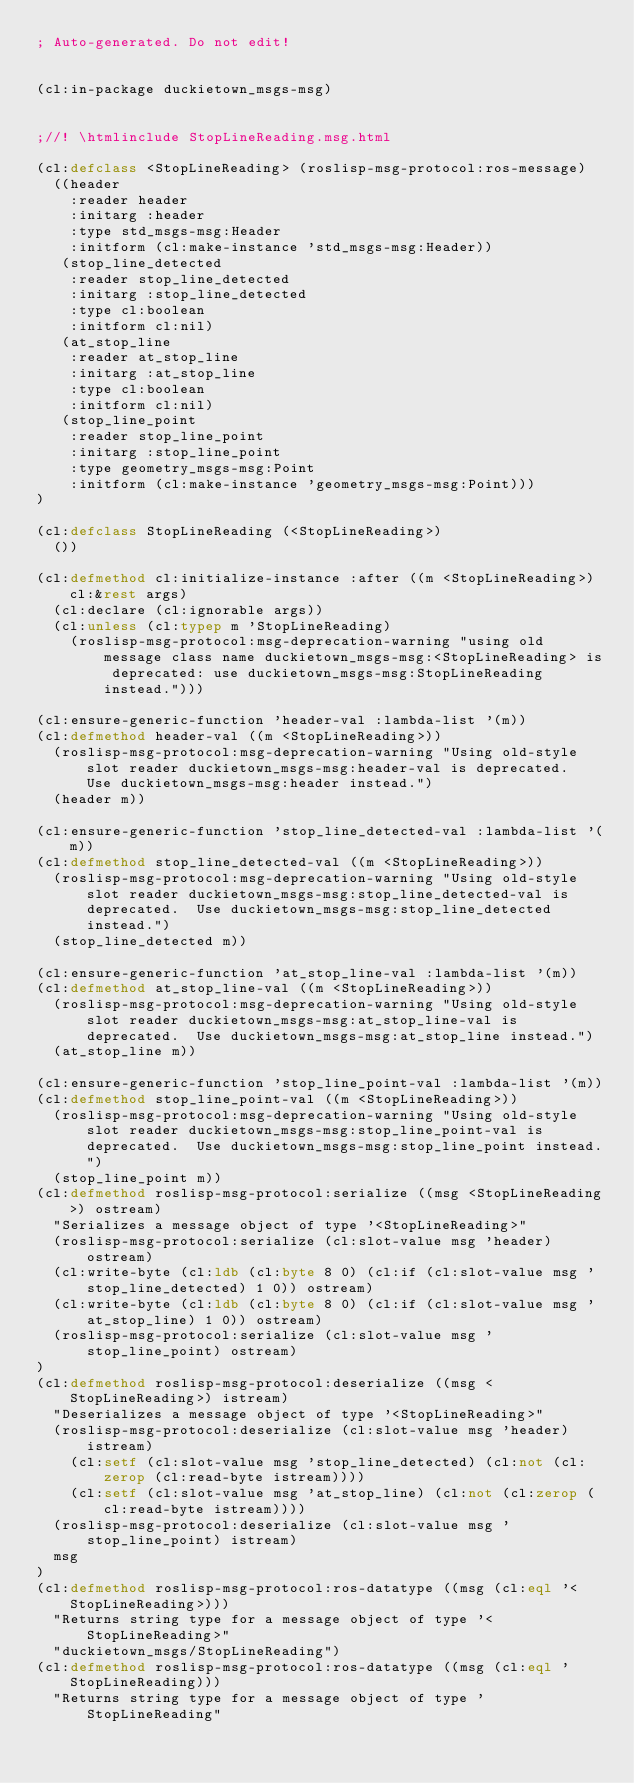<code> <loc_0><loc_0><loc_500><loc_500><_Lisp_>; Auto-generated. Do not edit!


(cl:in-package duckietown_msgs-msg)


;//! \htmlinclude StopLineReading.msg.html

(cl:defclass <StopLineReading> (roslisp-msg-protocol:ros-message)
  ((header
    :reader header
    :initarg :header
    :type std_msgs-msg:Header
    :initform (cl:make-instance 'std_msgs-msg:Header))
   (stop_line_detected
    :reader stop_line_detected
    :initarg :stop_line_detected
    :type cl:boolean
    :initform cl:nil)
   (at_stop_line
    :reader at_stop_line
    :initarg :at_stop_line
    :type cl:boolean
    :initform cl:nil)
   (stop_line_point
    :reader stop_line_point
    :initarg :stop_line_point
    :type geometry_msgs-msg:Point
    :initform (cl:make-instance 'geometry_msgs-msg:Point)))
)

(cl:defclass StopLineReading (<StopLineReading>)
  ())

(cl:defmethod cl:initialize-instance :after ((m <StopLineReading>) cl:&rest args)
  (cl:declare (cl:ignorable args))
  (cl:unless (cl:typep m 'StopLineReading)
    (roslisp-msg-protocol:msg-deprecation-warning "using old message class name duckietown_msgs-msg:<StopLineReading> is deprecated: use duckietown_msgs-msg:StopLineReading instead.")))

(cl:ensure-generic-function 'header-val :lambda-list '(m))
(cl:defmethod header-val ((m <StopLineReading>))
  (roslisp-msg-protocol:msg-deprecation-warning "Using old-style slot reader duckietown_msgs-msg:header-val is deprecated.  Use duckietown_msgs-msg:header instead.")
  (header m))

(cl:ensure-generic-function 'stop_line_detected-val :lambda-list '(m))
(cl:defmethod stop_line_detected-val ((m <StopLineReading>))
  (roslisp-msg-protocol:msg-deprecation-warning "Using old-style slot reader duckietown_msgs-msg:stop_line_detected-val is deprecated.  Use duckietown_msgs-msg:stop_line_detected instead.")
  (stop_line_detected m))

(cl:ensure-generic-function 'at_stop_line-val :lambda-list '(m))
(cl:defmethod at_stop_line-val ((m <StopLineReading>))
  (roslisp-msg-protocol:msg-deprecation-warning "Using old-style slot reader duckietown_msgs-msg:at_stop_line-val is deprecated.  Use duckietown_msgs-msg:at_stop_line instead.")
  (at_stop_line m))

(cl:ensure-generic-function 'stop_line_point-val :lambda-list '(m))
(cl:defmethod stop_line_point-val ((m <StopLineReading>))
  (roslisp-msg-protocol:msg-deprecation-warning "Using old-style slot reader duckietown_msgs-msg:stop_line_point-val is deprecated.  Use duckietown_msgs-msg:stop_line_point instead.")
  (stop_line_point m))
(cl:defmethod roslisp-msg-protocol:serialize ((msg <StopLineReading>) ostream)
  "Serializes a message object of type '<StopLineReading>"
  (roslisp-msg-protocol:serialize (cl:slot-value msg 'header) ostream)
  (cl:write-byte (cl:ldb (cl:byte 8 0) (cl:if (cl:slot-value msg 'stop_line_detected) 1 0)) ostream)
  (cl:write-byte (cl:ldb (cl:byte 8 0) (cl:if (cl:slot-value msg 'at_stop_line) 1 0)) ostream)
  (roslisp-msg-protocol:serialize (cl:slot-value msg 'stop_line_point) ostream)
)
(cl:defmethod roslisp-msg-protocol:deserialize ((msg <StopLineReading>) istream)
  "Deserializes a message object of type '<StopLineReading>"
  (roslisp-msg-protocol:deserialize (cl:slot-value msg 'header) istream)
    (cl:setf (cl:slot-value msg 'stop_line_detected) (cl:not (cl:zerop (cl:read-byte istream))))
    (cl:setf (cl:slot-value msg 'at_stop_line) (cl:not (cl:zerop (cl:read-byte istream))))
  (roslisp-msg-protocol:deserialize (cl:slot-value msg 'stop_line_point) istream)
  msg
)
(cl:defmethod roslisp-msg-protocol:ros-datatype ((msg (cl:eql '<StopLineReading>)))
  "Returns string type for a message object of type '<StopLineReading>"
  "duckietown_msgs/StopLineReading")
(cl:defmethod roslisp-msg-protocol:ros-datatype ((msg (cl:eql 'StopLineReading)))
  "Returns string type for a message object of type 'StopLineReading"</code> 